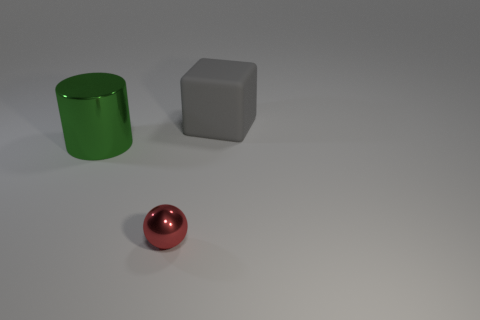Is the big metal object the same shape as the tiny object?
Offer a very short reply. No. What size is the metal object that is behind the tiny sphere?
Ensure brevity in your answer.  Large. What is the size of the green thing that is the same material as the red sphere?
Give a very brief answer. Large. Are there fewer matte things than tiny red metal cubes?
Your answer should be very brief. No. There is a green object that is the same size as the block; what is its material?
Ensure brevity in your answer.  Metal. Is the number of large rubber things greater than the number of gray metal objects?
Offer a terse response. Yes. How many other objects are the same color as the metallic cylinder?
Keep it short and to the point. 0. What number of metallic objects are both to the right of the big green metallic thing and behind the small sphere?
Your answer should be very brief. 0. Is there anything else that is the same size as the green shiny thing?
Provide a succinct answer. Yes. Are there more matte things to the left of the large metal cylinder than shiny things in front of the red metallic object?
Your answer should be compact. No. 